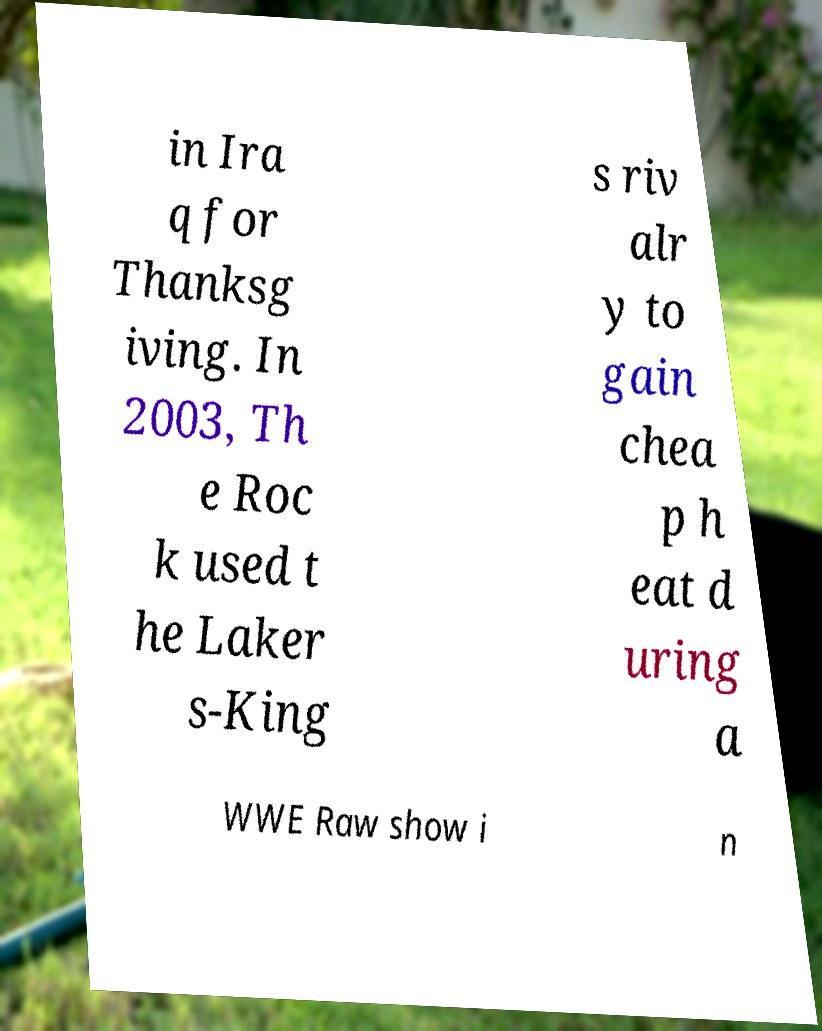There's text embedded in this image that I need extracted. Can you transcribe it verbatim? in Ira q for Thanksg iving. In 2003, Th e Roc k used t he Laker s-King s riv alr y to gain chea p h eat d uring a WWE Raw show i n 